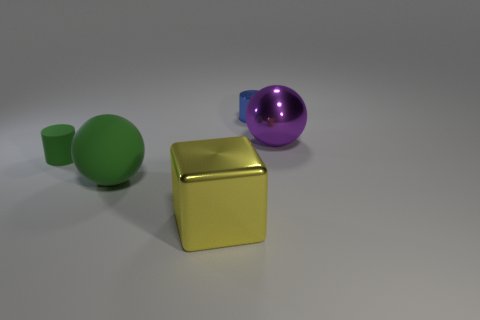Add 2 big cyan things. How many objects exist? 7 Subtract 2 cylinders. How many cylinders are left? 0 Subtract all tiny green objects. Subtract all yellow metallic blocks. How many objects are left? 3 Add 1 blue cylinders. How many blue cylinders are left? 2 Add 2 yellow metal things. How many yellow metal things exist? 3 Subtract all green cylinders. How many cylinders are left? 1 Subtract 0 brown cylinders. How many objects are left? 5 Subtract all cubes. How many objects are left? 4 Subtract all red cubes. Subtract all cyan balls. How many cubes are left? 1 Subtract all brown spheres. How many green cylinders are left? 1 